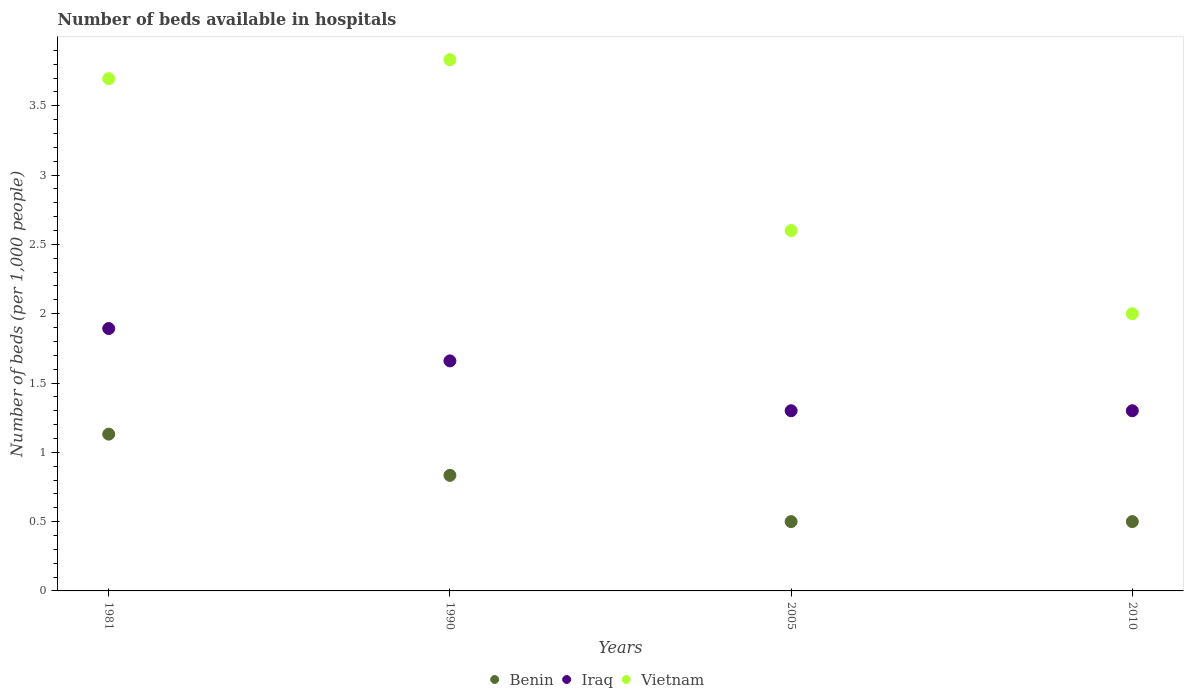How many different coloured dotlines are there?
Provide a succinct answer. 3. What is the number of beds in the hospiatls of in Vietnam in 1990?
Your answer should be compact. 3.83. Across all years, what is the maximum number of beds in the hospiatls of in Iraq?
Offer a very short reply. 1.89. Across all years, what is the minimum number of beds in the hospiatls of in Iraq?
Ensure brevity in your answer.  1.3. In which year was the number of beds in the hospiatls of in Iraq maximum?
Provide a succinct answer. 1981. In which year was the number of beds in the hospiatls of in Iraq minimum?
Your answer should be compact. 2005. What is the total number of beds in the hospiatls of in Vietnam in the graph?
Ensure brevity in your answer.  12.13. What is the difference between the number of beds in the hospiatls of in Benin in 1981 and that in 1990?
Offer a very short reply. 0.3. What is the average number of beds in the hospiatls of in Iraq per year?
Ensure brevity in your answer.  1.54. In the year 1990, what is the difference between the number of beds in the hospiatls of in Benin and number of beds in the hospiatls of in Vietnam?
Make the answer very short. -3. In how many years, is the number of beds in the hospiatls of in Vietnam greater than 3.7?
Keep it short and to the point. 1. What is the ratio of the number of beds in the hospiatls of in Vietnam in 1990 to that in 2005?
Offer a very short reply. 1.47. Is the number of beds in the hospiatls of in Benin in 1990 less than that in 2010?
Give a very brief answer. No. What is the difference between the highest and the second highest number of beds in the hospiatls of in Benin?
Keep it short and to the point. 0.3. What is the difference between the highest and the lowest number of beds in the hospiatls of in Iraq?
Offer a terse response. 0.59. Is the sum of the number of beds in the hospiatls of in Vietnam in 2005 and 2010 greater than the maximum number of beds in the hospiatls of in Iraq across all years?
Give a very brief answer. Yes. Is it the case that in every year, the sum of the number of beds in the hospiatls of in Vietnam and number of beds in the hospiatls of in Benin  is greater than the number of beds in the hospiatls of in Iraq?
Make the answer very short. Yes. Is the number of beds in the hospiatls of in Vietnam strictly less than the number of beds in the hospiatls of in Benin over the years?
Your response must be concise. No. How many dotlines are there?
Make the answer very short. 3. How many years are there in the graph?
Your answer should be very brief. 4. What is the difference between two consecutive major ticks on the Y-axis?
Keep it short and to the point. 0.5. How are the legend labels stacked?
Provide a succinct answer. Horizontal. What is the title of the graph?
Your response must be concise. Number of beds available in hospitals. What is the label or title of the Y-axis?
Offer a very short reply. Number of beds (per 1,0 people). What is the Number of beds (per 1,000 people) in Benin in 1981?
Offer a very short reply. 1.13. What is the Number of beds (per 1,000 people) in Iraq in 1981?
Offer a terse response. 1.89. What is the Number of beds (per 1,000 people) of Vietnam in 1981?
Ensure brevity in your answer.  3.7. What is the Number of beds (per 1,000 people) of Benin in 1990?
Provide a succinct answer. 0.83. What is the Number of beds (per 1,000 people) of Iraq in 1990?
Provide a short and direct response. 1.66. What is the Number of beds (per 1,000 people) of Vietnam in 1990?
Keep it short and to the point. 3.83. What is the Number of beds (per 1,000 people) in Benin in 2005?
Provide a short and direct response. 0.5. What is the Number of beds (per 1,000 people) of Iraq in 2005?
Ensure brevity in your answer.  1.3. What is the Number of beds (per 1,000 people) in Vietnam in 2005?
Provide a short and direct response. 2.6. Across all years, what is the maximum Number of beds (per 1,000 people) in Benin?
Keep it short and to the point. 1.13. Across all years, what is the maximum Number of beds (per 1,000 people) in Iraq?
Ensure brevity in your answer.  1.89. Across all years, what is the maximum Number of beds (per 1,000 people) in Vietnam?
Provide a succinct answer. 3.83. Across all years, what is the minimum Number of beds (per 1,000 people) of Benin?
Provide a succinct answer. 0.5. Across all years, what is the minimum Number of beds (per 1,000 people) of Vietnam?
Offer a terse response. 2. What is the total Number of beds (per 1,000 people) in Benin in the graph?
Give a very brief answer. 2.97. What is the total Number of beds (per 1,000 people) in Iraq in the graph?
Provide a short and direct response. 6.15. What is the total Number of beds (per 1,000 people) in Vietnam in the graph?
Your response must be concise. 12.13. What is the difference between the Number of beds (per 1,000 people) of Benin in 1981 and that in 1990?
Provide a succinct answer. 0.3. What is the difference between the Number of beds (per 1,000 people) in Iraq in 1981 and that in 1990?
Your response must be concise. 0.23. What is the difference between the Number of beds (per 1,000 people) in Vietnam in 1981 and that in 1990?
Keep it short and to the point. -0.14. What is the difference between the Number of beds (per 1,000 people) of Benin in 1981 and that in 2005?
Ensure brevity in your answer.  0.63. What is the difference between the Number of beds (per 1,000 people) of Iraq in 1981 and that in 2005?
Provide a succinct answer. 0.59. What is the difference between the Number of beds (per 1,000 people) of Vietnam in 1981 and that in 2005?
Offer a terse response. 1.1. What is the difference between the Number of beds (per 1,000 people) in Benin in 1981 and that in 2010?
Your answer should be compact. 0.63. What is the difference between the Number of beds (per 1,000 people) in Iraq in 1981 and that in 2010?
Your answer should be very brief. 0.59. What is the difference between the Number of beds (per 1,000 people) in Vietnam in 1981 and that in 2010?
Provide a succinct answer. 1.7. What is the difference between the Number of beds (per 1,000 people) in Benin in 1990 and that in 2005?
Ensure brevity in your answer.  0.33. What is the difference between the Number of beds (per 1,000 people) in Iraq in 1990 and that in 2005?
Provide a succinct answer. 0.36. What is the difference between the Number of beds (per 1,000 people) in Vietnam in 1990 and that in 2005?
Provide a short and direct response. 1.23. What is the difference between the Number of beds (per 1,000 people) of Benin in 1990 and that in 2010?
Make the answer very short. 0.33. What is the difference between the Number of beds (per 1,000 people) in Iraq in 1990 and that in 2010?
Provide a short and direct response. 0.36. What is the difference between the Number of beds (per 1,000 people) of Vietnam in 1990 and that in 2010?
Your answer should be very brief. 1.83. What is the difference between the Number of beds (per 1,000 people) of Benin in 2005 and that in 2010?
Offer a terse response. 0. What is the difference between the Number of beds (per 1,000 people) of Vietnam in 2005 and that in 2010?
Make the answer very short. 0.6. What is the difference between the Number of beds (per 1,000 people) in Benin in 1981 and the Number of beds (per 1,000 people) in Iraq in 1990?
Your answer should be very brief. -0.53. What is the difference between the Number of beds (per 1,000 people) in Benin in 1981 and the Number of beds (per 1,000 people) in Vietnam in 1990?
Make the answer very short. -2.7. What is the difference between the Number of beds (per 1,000 people) of Iraq in 1981 and the Number of beds (per 1,000 people) of Vietnam in 1990?
Give a very brief answer. -1.94. What is the difference between the Number of beds (per 1,000 people) in Benin in 1981 and the Number of beds (per 1,000 people) in Iraq in 2005?
Your response must be concise. -0.17. What is the difference between the Number of beds (per 1,000 people) in Benin in 1981 and the Number of beds (per 1,000 people) in Vietnam in 2005?
Your response must be concise. -1.47. What is the difference between the Number of beds (per 1,000 people) of Iraq in 1981 and the Number of beds (per 1,000 people) of Vietnam in 2005?
Your response must be concise. -0.71. What is the difference between the Number of beds (per 1,000 people) in Benin in 1981 and the Number of beds (per 1,000 people) in Iraq in 2010?
Give a very brief answer. -0.17. What is the difference between the Number of beds (per 1,000 people) of Benin in 1981 and the Number of beds (per 1,000 people) of Vietnam in 2010?
Your response must be concise. -0.87. What is the difference between the Number of beds (per 1,000 people) in Iraq in 1981 and the Number of beds (per 1,000 people) in Vietnam in 2010?
Your answer should be compact. -0.11. What is the difference between the Number of beds (per 1,000 people) of Benin in 1990 and the Number of beds (per 1,000 people) of Iraq in 2005?
Ensure brevity in your answer.  -0.47. What is the difference between the Number of beds (per 1,000 people) in Benin in 1990 and the Number of beds (per 1,000 people) in Vietnam in 2005?
Provide a short and direct response. -1.77. What is the difference between the Number of beds (per 1,000 people) in Iraq in 1990 and the Number of beds (per 1,000 people) in Vietnam in 2005?
Your answer should be very brief. -0.94. What is the difference between the Number of beds (per 1,000 people) in Benin in 1990 and the Number of beds (per 1,000 people) in Iraq in 2010?
Offer a very short reply. -0.47. What is the difference between the Number of beds (per 1,000 people) of Benin in 1990 and the Number of beds (per 1,000 people) of Vietnam in 2010?
Your response must be concise. -1.17. What is the difference between the Number of beds (per 1,000 people) in Iraq in 1990 and the Number of beds (per 1,000 people) in Vietnam in 2010?
Your answer should be very brief. -0.34. What is the difference between the Number of beds (per 1,000 people) of Iraq in 2005 and the Number of beds (per 1,000 people) of Vietnam in 2010?
Your answer should be very brief. -0.7. What is the average Number of beds (per 1,000 people) in Benin per year?
Provide a succinct answer. 0.74. What is the average Number of beds (per 1,000 people) of Iraq per year?
Your answer should be very brief. 1.54. What is the average Number of beds (per 1,000 people) in Vietnam per year?
Ensure brevity in your answer.  3.03. In the year 1981, what is the difference between the Number of beds (per 1,000 people) in Benin and Number of beds (per 1,000 people) in Iraq?
Make the answer very short. -0.76. In the year 1981, what is the difference between the Number of beds (per 1,000 people) of Benin and Number of beds (per 1,000 people) of Vietnam?
Your answer should be very brief. -2.56. In the year 1981, what is the difference between the Number of beds (per 1,000 people) in Iraq and Number of beds (per 1,000 people) in Vietnam?
Give a very brief answer. -1.8. In the year 1990, what is the difference between the Number of beds (per 1,000 people) in Benin and Number of beds (per 1,000 people) in Iraq?
Offer a terse response. -0.83. In the year 1990, what is the difference between the Number of beds (per 1,000 people) of Benin and Number of beds (per 1,000 people) of Vietnam?
Your response must be concise. -3. In the year 1990, what is the difference between the Number of beds (per 1,000 people) of Iraq and Number of beds (per 1,000 people) of Vietnam?
Offer a terse response. -2.17. In the year 2005, what is the difference between the Number of beds (per 1,000 people) in Benin and Number of beds (per 1,000 people) in Iraq?
Offer a terse response. -0.8. In the year 2010, what is the difference between the Number of beds (per 1,000 people) in Benin and Number of beds (per 1,000 people) in Iraq?
Give a very brief answer. -0.8. In the year 2010, what is the difference between the Number of beds (per 1,000 people) of Iraq and Number of beds (per 1,000 people) of Vietnam?
Give a very brief answer. -0.7. What is the ratio of the Number of beds (per 1,000 people) of Benin in 1981 to that in 1990?
Provide a short and direct response. 1.36. What is the ratio of the Number of beds (per 1,000 people) in Iraq in 1981 to that in 1990?
Provide a succinct answer. 1.14. What is the ratio of the Number of beds (per 1,000 people) of Benin in 1981 to that in 2005?
Offer a very short reply. 2.26. What is the ratio of the Number of beds (per 1,000 people) of Iraq in 1981 to that in 2005?
Your response must be concise. 1.46. What is the ratio of the Number of beds (per 1,000 people) in Vietnam in 1981 to that in 2005?
Your answer should be compact. 1.42. What is the ratio of the Number of beds (per 1,000 people) of Benin in 1981 to that in 2010?
Give a very brief answer. 2.26. What is the ratio of the Number of beds (per 1,000 people) in Iraq in 1981 to that in 2010?
Offer a very short reply. 1.46. What is the ratio of the Number of beds (per 1,000 people) in Vietnam in 1981 to that in 2010?
Offer a terse response. 1.85. What is the ratio of the Number of beds (per 1,000 people) of Benin in 1990 to that in 2005?
Make the answer very short. 1.67. What is the ratio of the Number of beds (per 1,000 people) in Iraq in 1990 to that in 2005?
Keep it short and to the point. 1.28. What is the ratio of the Number of beds (per 1,000 people) of Vietnam in 1990 to that in 2005?
Your answer should be compact. 1.47. What is the ratio of the Number of beds (per 1,000 people) in Benin in 1990 to that in 2010?
Your response must be concise. 1.67. What is the ratio of the Number of beds (per 1,000 people) in Iraq in 1990 to that in 2010?
Your answer should be very brief. 1.28. What is the ratio of the Number of beds (per 1,000 people) of Vietnam in 1990 to that in 2010?
Keep it short and to the point. 1.92. What is the ratio of the Number of beds (per 1,000 people) of Benin in 2005 to that in 2010?
Your answer should be very brief. 1. What is the ratio of the Number of beds (per 1,000 people) in Iraq in 2005 to that in 2010?
Your response must be concise. 1. What is the difference between the highest and the second highest Number of beds (per 1,000 people) in Benin?
Make the answer very short. 0.3. What is the difference between the highest and the second highest Number of beds (per 1,000 people) of Iraq?
Provide a succinct answer. 0.23. What is the difference between the highest and the second highest Number of beds (per 1,000 people) in Vietnam?
Keep it short and to the point. 0.14. What is the difference between the highest and the lowest Number of beds (per 1,000 people) of Benin?
Ensure brevity in your answer.  0.63. What is the difference between the highest and the lowest Number of beds (per 1,000 people) of Iraq?
Ensure brevity in your answer.  0.59. What is the difference between the highest and the lowest Number of beds (per 1,000 people) in Vietnam?
Your response must be concise. 1.83. 